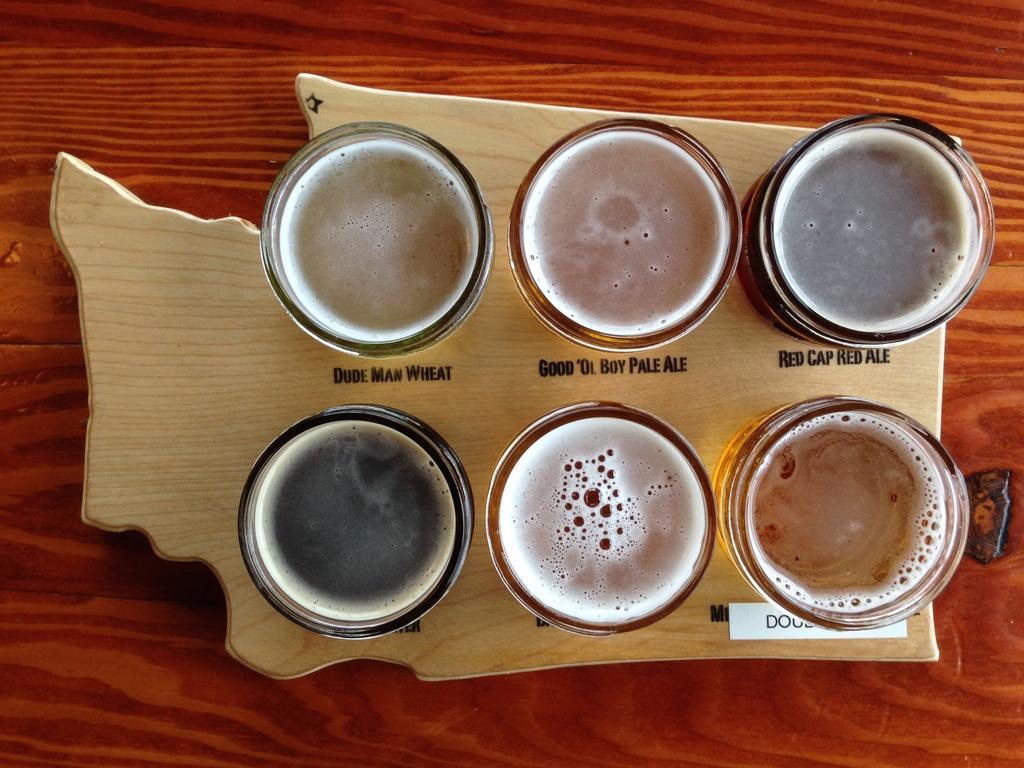In one or two sentences, can you explain what this image depicts? In this image there is a plate on the wooden table. On the plate there are six glasses with some juice in it. In between the glasses there is some text on the plate. 